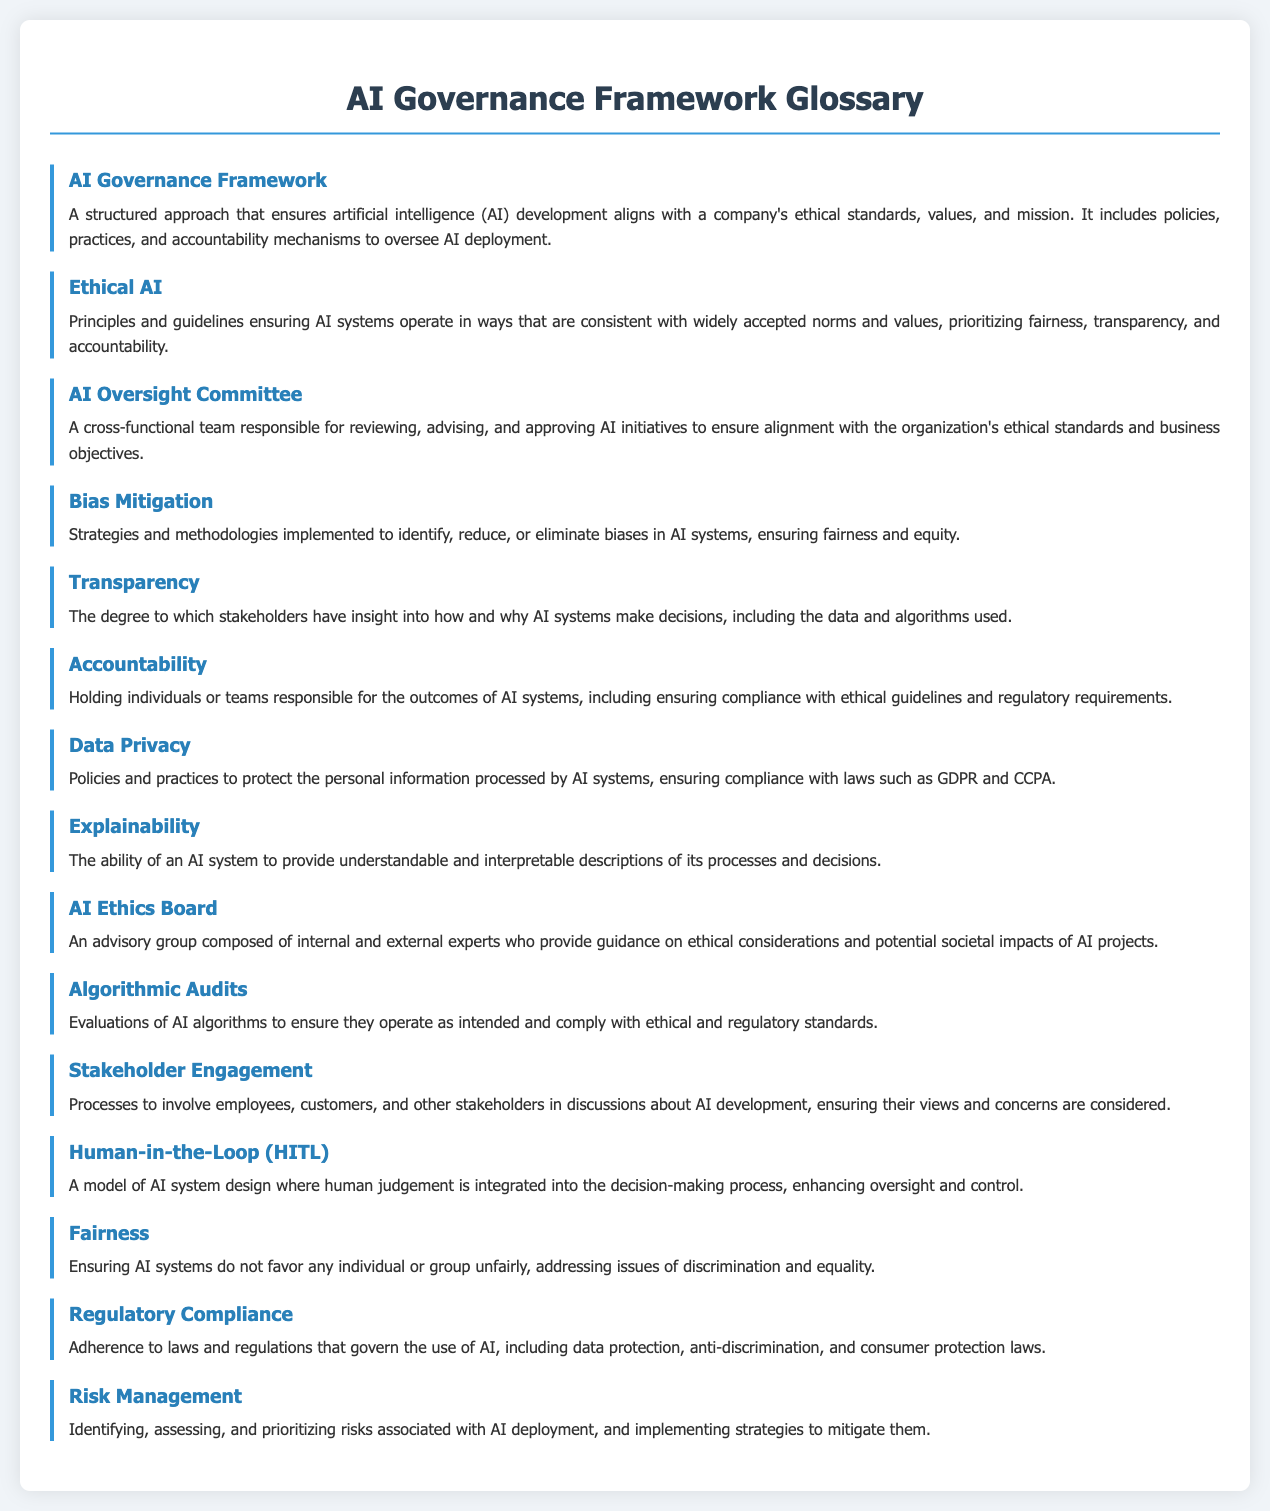What is the term used for ensuring that AI systems adhere to ethical standards? The document defines "AI Governance Framework" as a structured approach that ensures AI development aligns with ethical standards, values, and mission.
Answer: AI Governance Framework Who is responsible for approving AI initiatives according to the glossary? The "AI Oversight Committee" is defined as a cross-functional team responsible for reviewing, advising, and approving AI initiatives.
Answer: AI Oversight Committee What term describes the strategies implemented to reduce biases in AI systems? The glossary uses the term "Bias Mitigation" to refer to strategies and methodologies aimed at identifying, reducing, or eliminating biases.
Answer: Bias Mitigation What is the main focus of an AI Ethics Board? The "AI Ethics Board" is described as an advisory group providing guidance on ethical considerations and potential societal impacts of AI projects.
Answer: Guidance on ethical considerations How does the document define the term for ensuring AI system fairness? The glossary defines "Fairness" as ensuring AI systems do not favor any individual or group unfairly, addressing issues of discrimination and equality.
Answer: Fairness What does "Stakeholder Engagement" refer to in the context of the document? The term "Stakeholder Engagement" refers to processes that involve employees, customers, and other stakeholders in discussions about AI development.
Answer: Involve stakeholders in discussions What aspect does "Transparency" focus on regarding AI systems? Transparency in the document is defined as the degree to which stakeholders have insight into how and why AI systems make decisions.
Answer: Insight into AI decisions What framework ensures compliance with data protection laws? The term "Data Privacy" covers policies and practices to protect personal information processed by AI systems, ensuring compliance with laws.
Answer: Data Privacy How is "Risk Management" defined in the context of AI deployment? "Risk Management" is described as identifying, assessing, and prioritizing risks associated with AI deployment, along with strategies to mitigate them.
Answer: Identifying and prioritizing risks 